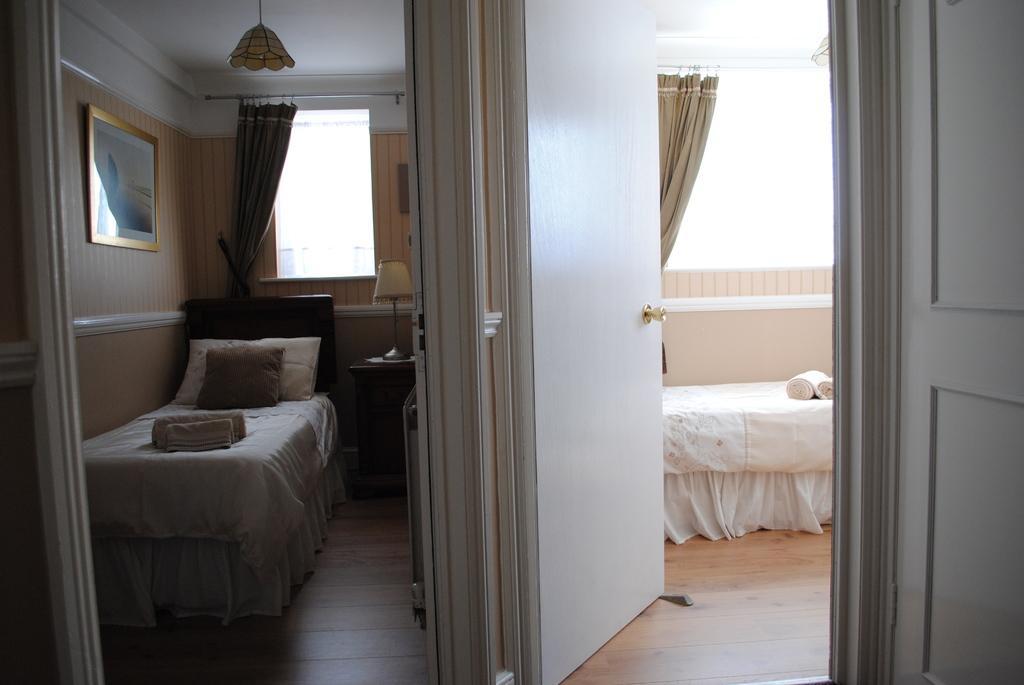Please provide a concise description of this image. There are two white beds in two different rooms. 